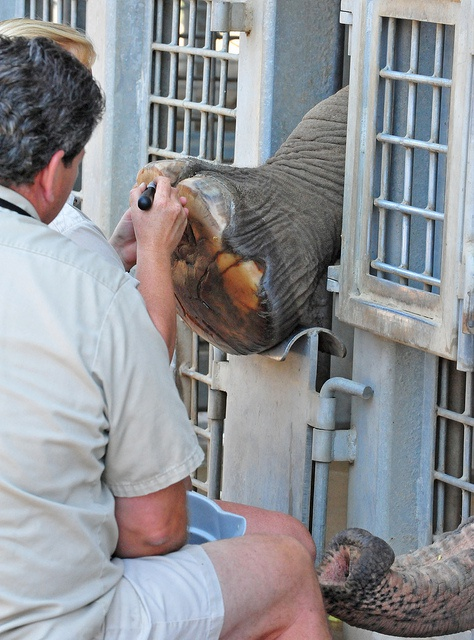Describe the objects in this image and their specific colors. I can see people in darkgray and lightgray tones and elephant in darkgray, gray, black, and maroon tones in this image. 